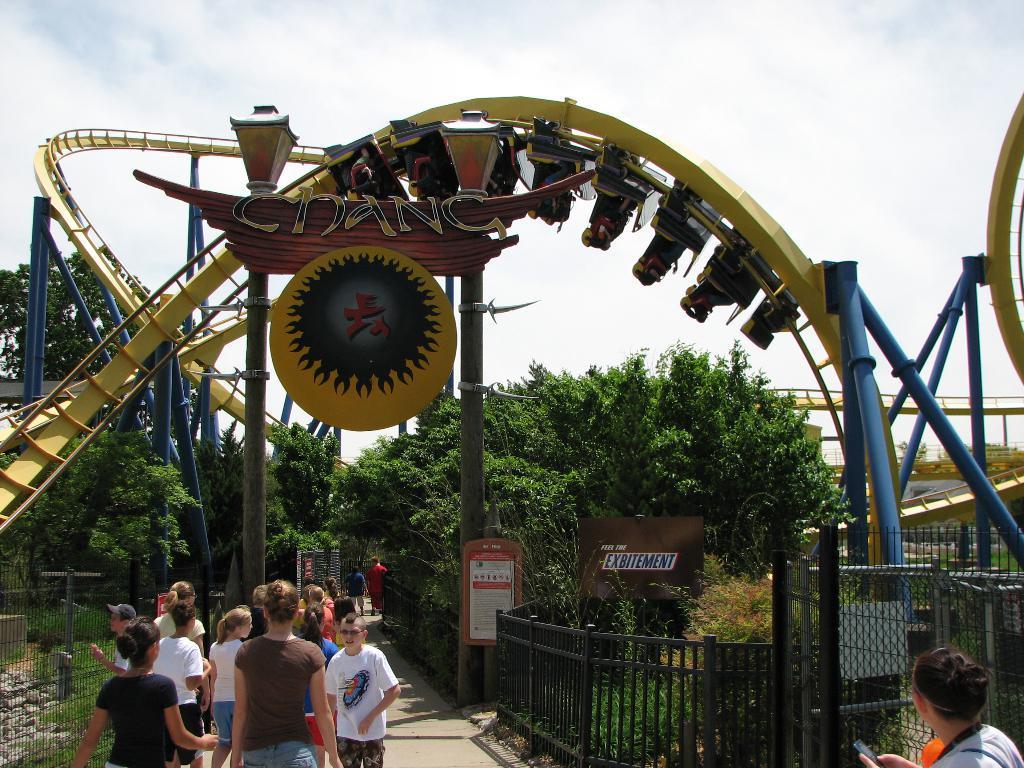Could you give a brief overview of what you see in this image? There are groups of people standing. These are the barricades. I can see the boards attached to the poles. This looks like a roller coaster. I can see a name board attached to the pole. This looks like a light pole. This is a fence. These are the trees. I can see few people sitting in the roller coaster. 